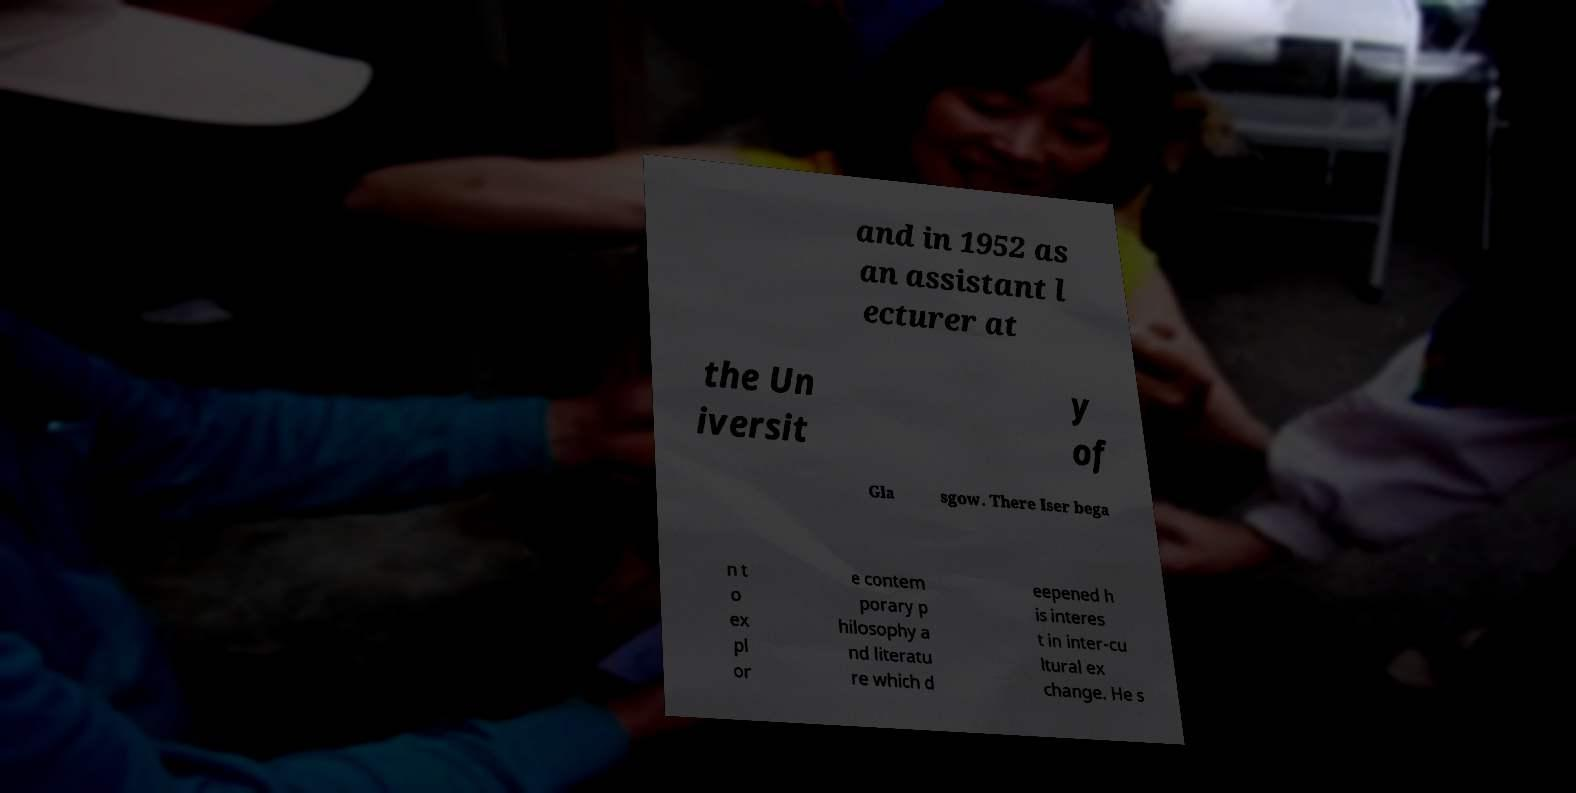There's text embedded in this image that I need extracted. Can you transcribe it verbatim? and in 1952 as an assistant l ecturer at the Un iversit y of Gla sgow. There Iser bega n t o ex pl or e contem porary p hilosophy a nd literatu re which d eepened h is interes t in inter-cu ltural ex change. He s 